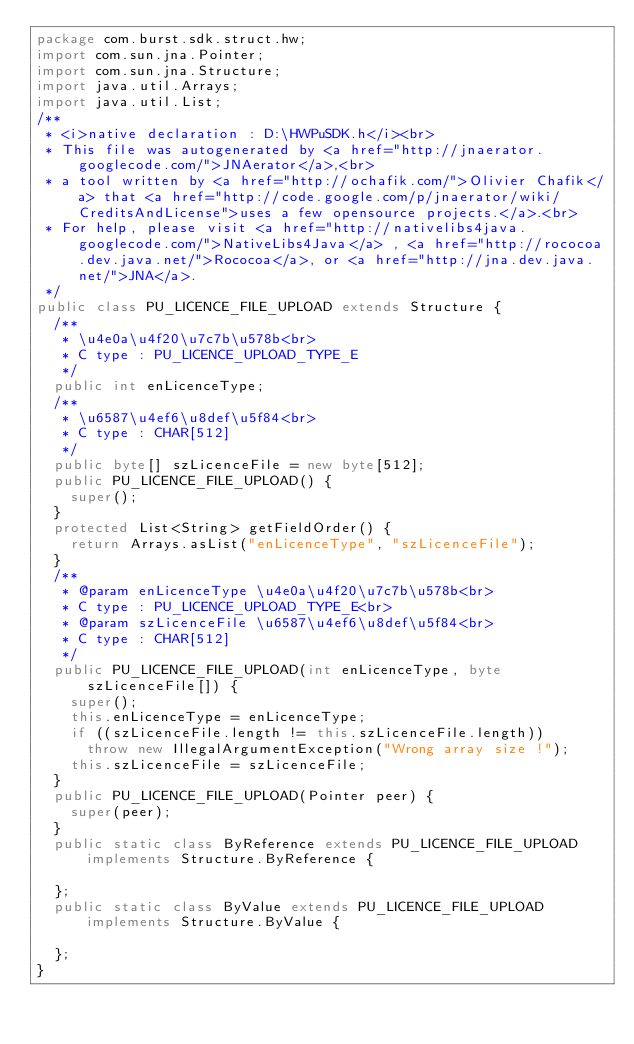<code> <loc_0><loc_0><loc_500><loc_500><_Java_>package com.burst.sdk.struct.hw;
import com.sun.jna.Pointer;
import com.sun.jna.Structure;
import java.util.Arrays;
import java.util.List;
/**
 * <i>native declaration : D:\HWPuSDK.h</i><br>
 * This file was autogenerated by <a href="http://jnaerator.googlecode.com/">JNAerator</a>,<br>
 * a tool written by <a href="http://ochafik.com/">Olivier Chafik</a> that <a href="http://code.google.com/p/jnaerator/wiki/CreditsAndLicense">uses a few opensource projects.</a>.<br>
 * For help, please visit <a href="http://nativelibs4java.googlecode.com/">NativeLibs4Java</a> , <a href="http://rococoa.dev.java.net/">Rococoa</a>, or <a href="http://jna.dev.java.net/">JNA</a>.
 */
public class PU_LICENCE_FILE_UPLOAD extends Structure {
	/**
	 * \u4e0a\u4f20\u7c7b\u578b<br>
	 * C type : PU_LICENCE_UPLOAD_TYPE_E
	 */
	public int enLicenceType;
	/**
	 * \u6587\u4ef6\u8def\u5f84<br>
	 * C type : CHAR[512]
	 */
	public byte[] szLicenceFile = new byte[512];
	public PU_LICENCE_FILE_UPLOAD() {
		super();
	}
	protected List<String> getFieldOrder() {
		return Arrays.asList("enLicenceType", "szLicenceFile");
	}
	/**
	 * @param enLicenceType \u4e0a\u4f20\u7c7b\u578b<br>
	 * C type : PU_LICENCE_UPLOAD_TYPE_E<br>
	 * @param szLicenceFile \u6587\u4ef6\u8def\u5f84<br>
	 * C type : CHAR[512]
	 */
	public PU_LICENCE_FILE_UPLOAD(int enLicenceType, byte szLicenceFile[]) {
		super();
		this.enLicenceType = enLicenceType;
		if ((szLicenceFile.length != this.szLicenceFile.length)) 
			throw new IllegalArgumentException("Wrong array size !");
		this.szLicenceFile = szLicenceFile;
	}
	public PU_LICENCE_FILE_UPLOAD(Pointer peer) {
		super(peer);
	}
	public static class ByReference extends PU_LICENCE_FILE_UPLOAD implements Structure.ByReference {
		
	};
	public static class ByValue extends PU_LICENCE_FILE_UPLOAD implements Structure.ByValue {
		
	};
}
</code> 